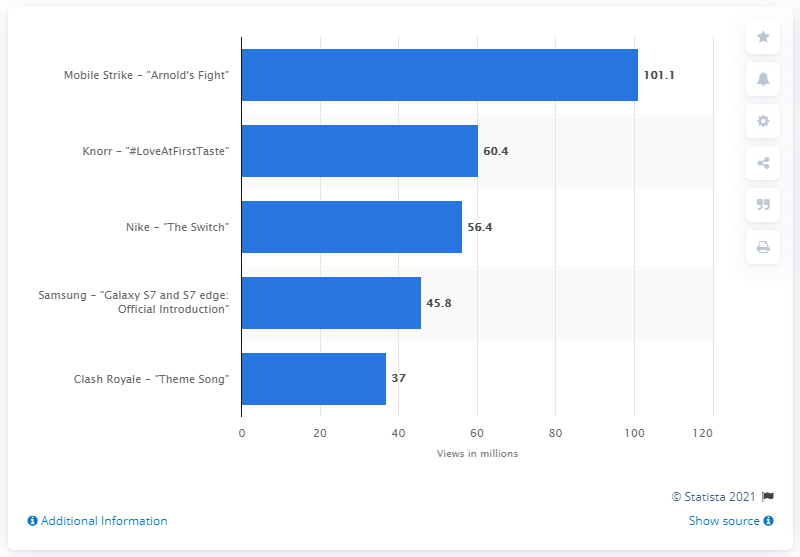Identify some key points in this picture. The views for the video "Knorr: Love at First Taste" were 60.4.. In 2016, the mobile game "Mobile Strike: Arnold's Fight" received 101.1 million views worldwide. 